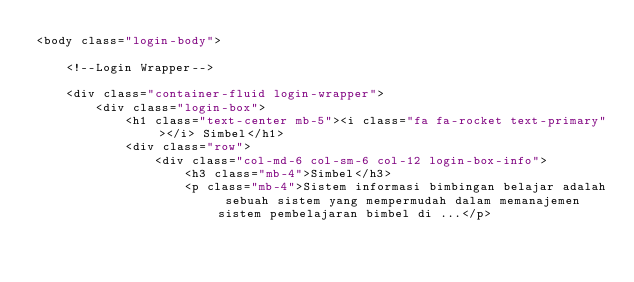Convert code to text. <code><loc_0><loc_0><loc_500><loc_500><_PHP_><body class="login-body">

    <!--Login Wrapper-->

    <div class="container-fluid login-wrapper">
        <div class="login-box">
            <h1 class="text-center mb-5"><i class="fa fa-rocket text-primary"></i> Simbel</h1>
            <div class="row">
                <div class="col-md-6 col-sm-6 col-12 login-box-info">
                    <h3 class="mb-4">Simbel</h3>
                    <p class="mb-4">Sistem informasi bimbingan belajar adalah sebuah sistem yang mempermudah dalam memanajemen sistem pembelajaran bimbel di ...</p></code> 